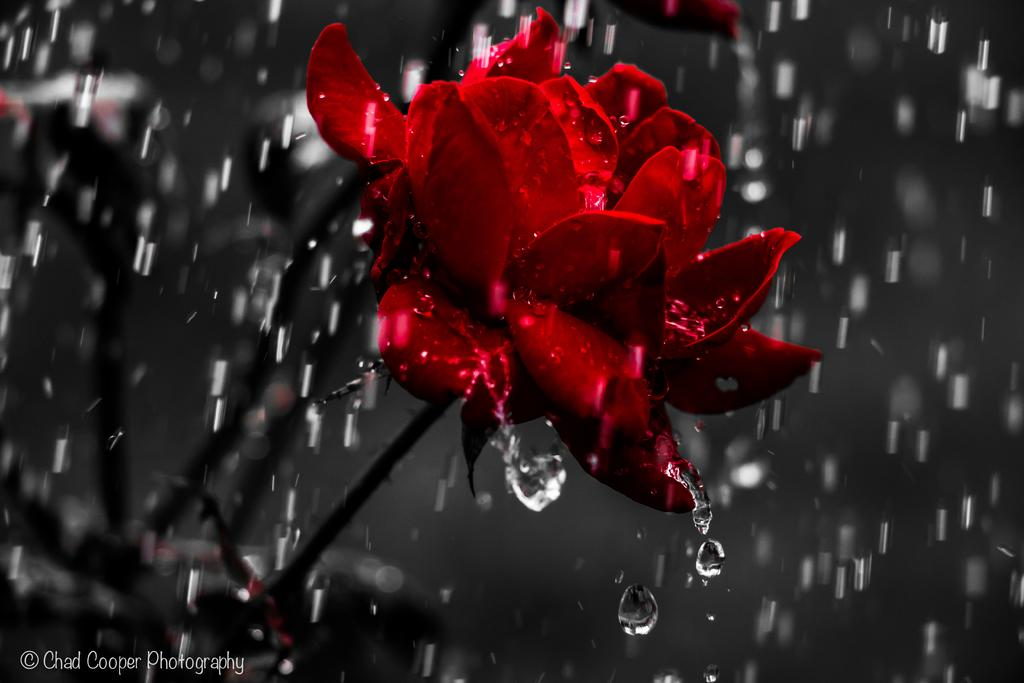What type of plant is present in the image? There are flowers on a plant in the image. What is the weather like in the image? It is raining in the image. Can you describe any additional details about the image? There are water droplets visible in the image. What type of error can be seen in the image? There is no error present in the image; it is a photograph of a plant with flowers during rain. 